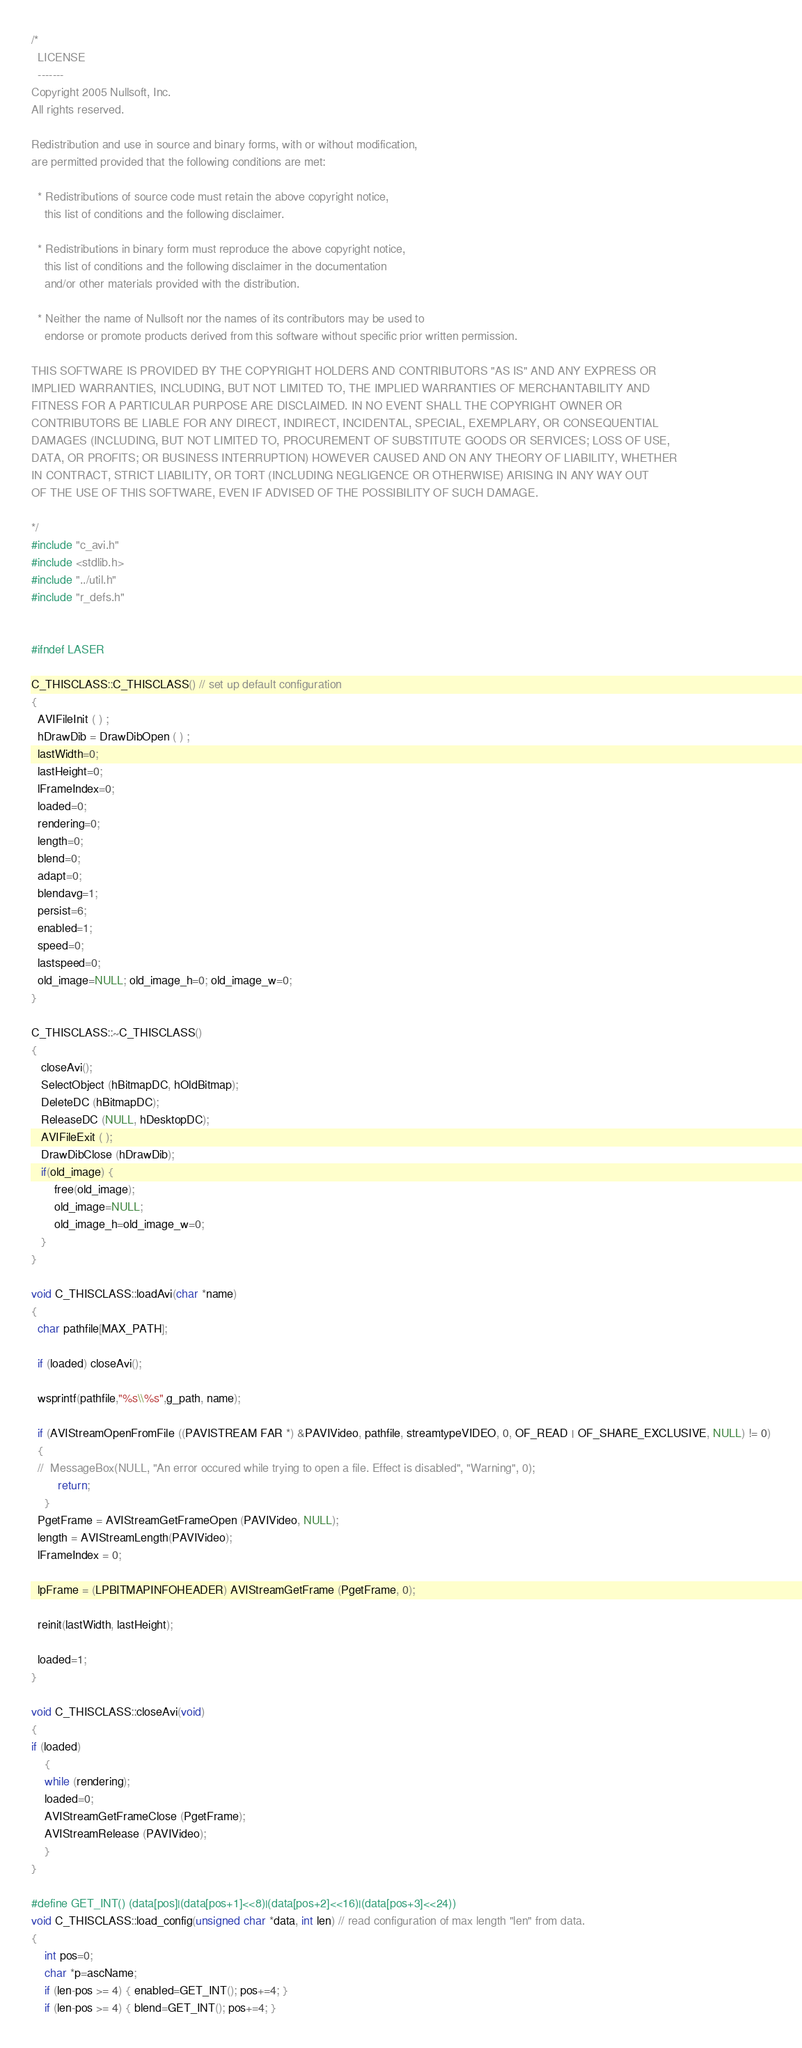<code> <loc_0><loc_0><loc_500><loc_500><_C++_>/*
  LICENSE
  -------
Copyright 2005 Nullsoft, Inc.
All rights reserved.

Redistribution and use in source and binary forms, with or without modification, 
are permitted provided that the following conditions are met:

  * Redistributions of source code must retain the above copyright notice,
    this list of conditions and the following disclaimer. 

  * Redistributions in binary form must reproduce the above copyright notice,
    this list of conditions and the following disclaimer in the documentation
    and/or other materials provided with the distribution. 

  * Neither the name of Nullsoft nor the names of its contributors may be used to 
    endorse or promote products derived from this software without specific prior written permission. 
 
THIS SOFTWARE IS PROVIDED BY THE COPYRIGHT HOLDERS AND CONTRIBUTORS "AS IS" AND ANY EXPRESS OR 
IMPLIED WARRANTIES, INCLUDING, BUT NOT LIMITED TO, THE IMPLIED WARRANTIES OF MERCHANTABILITY AND 
FITNESS FOR A PARTICULAR PURPOSE ARE DISCLAIMED. IN NO EVENT SHALL THE COPYRIGHT OWNER OR 
CONTRIBUTORS BE LIABLE FOR ANY DIRECT, INDIRECT, INCIDENTAL, SPECIAL, EXEMPLARY, OR CONSEQUENTIAL
DAMAGES (INCLUDING, BUT NOT LIMITED TO, PROCUREMENT OF SUBSTITUTE GOODS OR SERVICES; LOSS OF USE,
DATA, OR PROFITS; OR BUSINESS INTERRUPTION) HOWEVER CAUSED AND ON ANY THEORY OF LIABILITY, WHETHER
IN CONTRACT, STRICT LIABILITY, OR TORT (INCLUDING NEGLIGENCE OR OTHERWISE) ARISING IN ANY WAY OUT 
OF THE USE OF THIS SOFTWARE, EVEN IF ADVISED OF THE POSSIBILITY OF SUCH DAMAGE.

*/
#include "c_avi.h"
#include <stdlib.h>
#include "../util.h"
#include "r_defs.h"


#ifndef LASER

C_THISCLASS::C_THISCLASS() // set up default configuration
{
  AVIFileInit ( ) ; 
  hDrawDib = DrawDibOpen ( ) ; 
  lastWidth=0;
  lastHeight=0;
  lFrameIndex=0;
  loaded=0;
  rendering=0;
  length=0;
  blend=0;
  adapt=0;
  blendavg=1;
  persist=6;
  enabled=1;
  speed=0;
  lastspeed=0;
  old_image=NULL; old_image_h=0; old_image_w=0;
}

C_THISCLASS::~C_THISCLASS()
{
   closeAvi();
   SelectObject (hBitmapDC, hOldBitmap); 
   DeleteDC (hBitmapDC); 
   ReleaseDC (NULL, hDesktopDC); 
   AVIFileExit ( ); 
   DrawDibClose (hDrawDib); 
   if(old_image) {
	   free(old_image);
	   old_image=NULL;
	   old_image_h=old_image_w=0;
   }
}

void C_THISCLASS::loadAvi(char *name)
{
  char pathfile[MAX_PATH];

  if (loaded) closeAvi();

  wsprintf(pathfile,"%s\\%s",g_path, name);

  if (AVIStreamOpenFromFile ((PAVISTREAM FAR *) &PAVIVideo, pathfile, streamtypeVIDEO, 0, OF_READ | OF_SHARE_EXCLUSIVE, NULL) != 0)
  {
  //	MessageBox(NULL, "An error occured while trying to open a file. Effect is disabled", "Warning", 0);
	    return;
	}
  PgetFrame = AVIStreamGetFrameOpen (PAVIVideo, NULL); 
  length = AVIStreamLength(PAVIVideo);
  lFrameIndex = 0;

  lpFrame = (LPBITMAPINFOHEADER) AVIStreamGetFrame (PgetFrame, 0); 

  reinit(lastWidth, lastHeight);

  loaded=1;
}

void C_THISCLASS::closeAvi(void)
{
if (loaded)
	{
	while (rendering);
    loaded=0;
    AVIStreamGetFrameClose (PgetFrame); 
    AVIStreamRelease (PAVIVideo); 
	}
}

#define GET_INT() (data[pos]|(data[pos+1]<<8)|(data[pos+2]<<16)|(data[pos+3]<<24))
void C_THISCLASS::load_config(unsigned char *data, int len) // read configuration of max length "len" from data.
{
	int pos=0;
	char *p=ascName;
	if (len-pos >= 4) { enabled=GET_INT(); pos+=4; }
	if (len-pos >= 4) { blend=GET_INT(); pos+=4; }</code> 